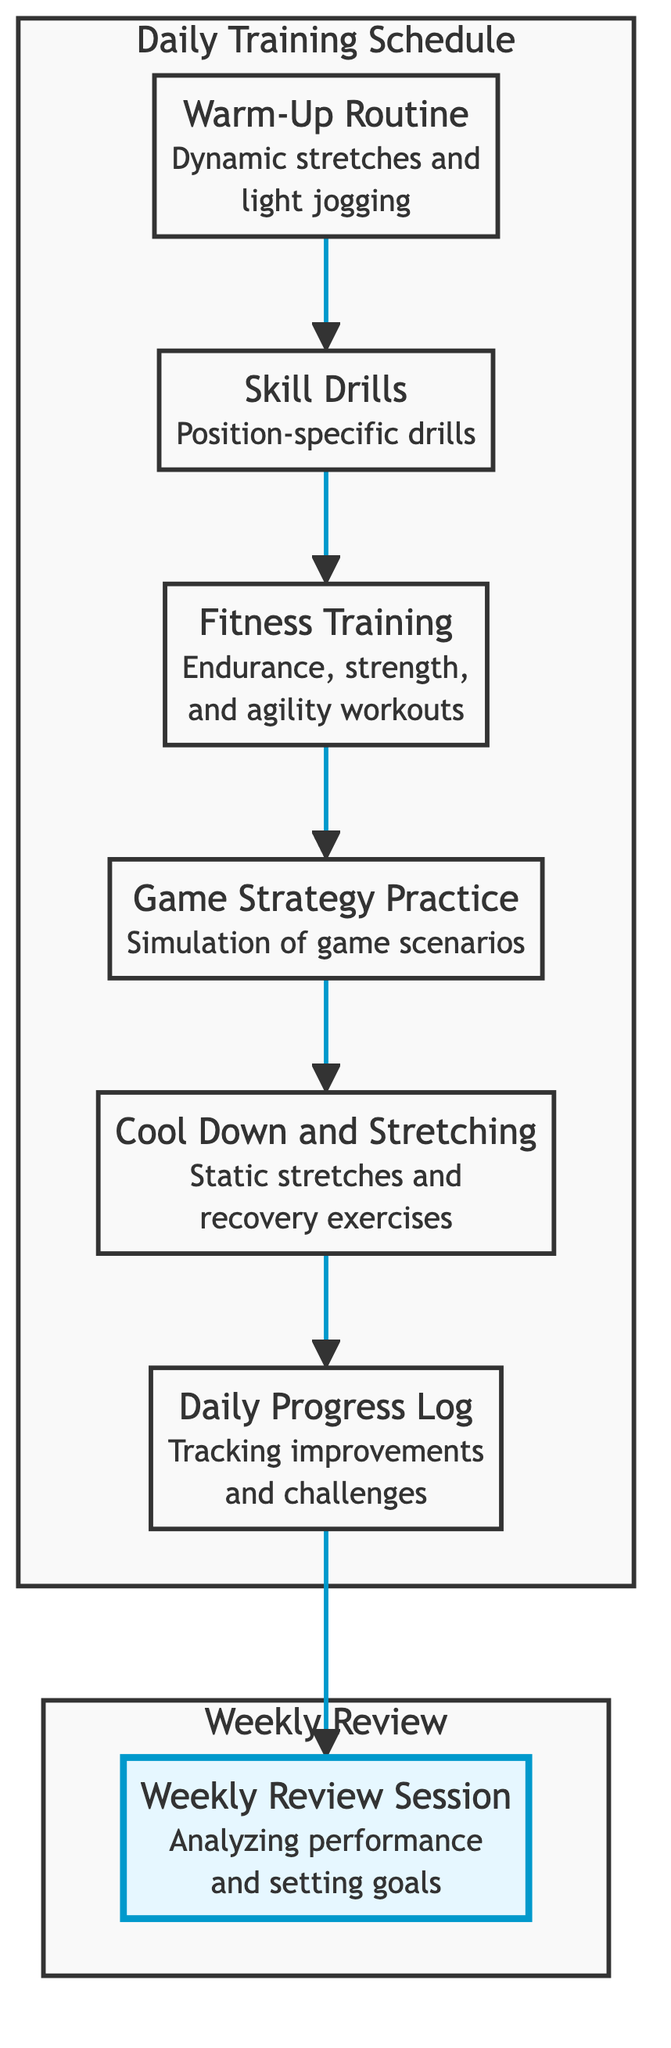What is the first step in the daily training schedule? The first step is "Warm-Up Routine," which is indicated at the beginning of the flow chart and is the starting node of the daily training process.
Answer: Warm-Up Routine How many nodes are in the daily training schedule? The daily training schedule consists of six nodes: Warm-Up Routine, Skill Drills, Fitness Training, Game Strategy Practice, Cool Down and Stretching, and Daily Progress Log.
Answer: Six What follows "Strategy" in the daily training flow? After "Game Strategy Practice" (labeled as Strategy), the next step is "Cool Down and Stretching," which is directly linked as the following node in the flow.
Answer: Cool Down and Stretching Which node is designated for tracking daily improvements? "Daily Progress Log" is the designated node for tracking daily improvements, as indicated in the diagram.
Answer: Daily Progress Log What is the last step in the daily training schedule? The last step in the daily training schedule is "Weekly Review Session," which is part of the weekly review subgraph connected to the Daily Progress Log.
Answer: Weekly Review Session What type of drills are involved in "Skill Drills"? "Skill Drills" involves position-specific drills focusing on techniques such as passing, tackling, and ball handling. This detail is described in the node.
Answer: Position-specific drills What is the purpose of the "Weekly Review Session"? The purpose of the "Weekly Review Session" is to analyze performance and set goals for upcoming training, as stated in the description of the node within the weekly review subgraph.
Answer: Analyzing performance and setting goals Which node comes after "Fitness Training" in the daily flow? The node that comes after "Fitness Training" is "Game Strategy Practice," which directly connects to it in the diagram flow.
Answer: Game Strategy Practice What type of exercises are included in "Cool Down and Stretching"? "Cool Down and Stretching" includes static stretches and recovery exercises, as described in the corresponding node of the diagram.
Answer: Static stretches and recovery exercises 